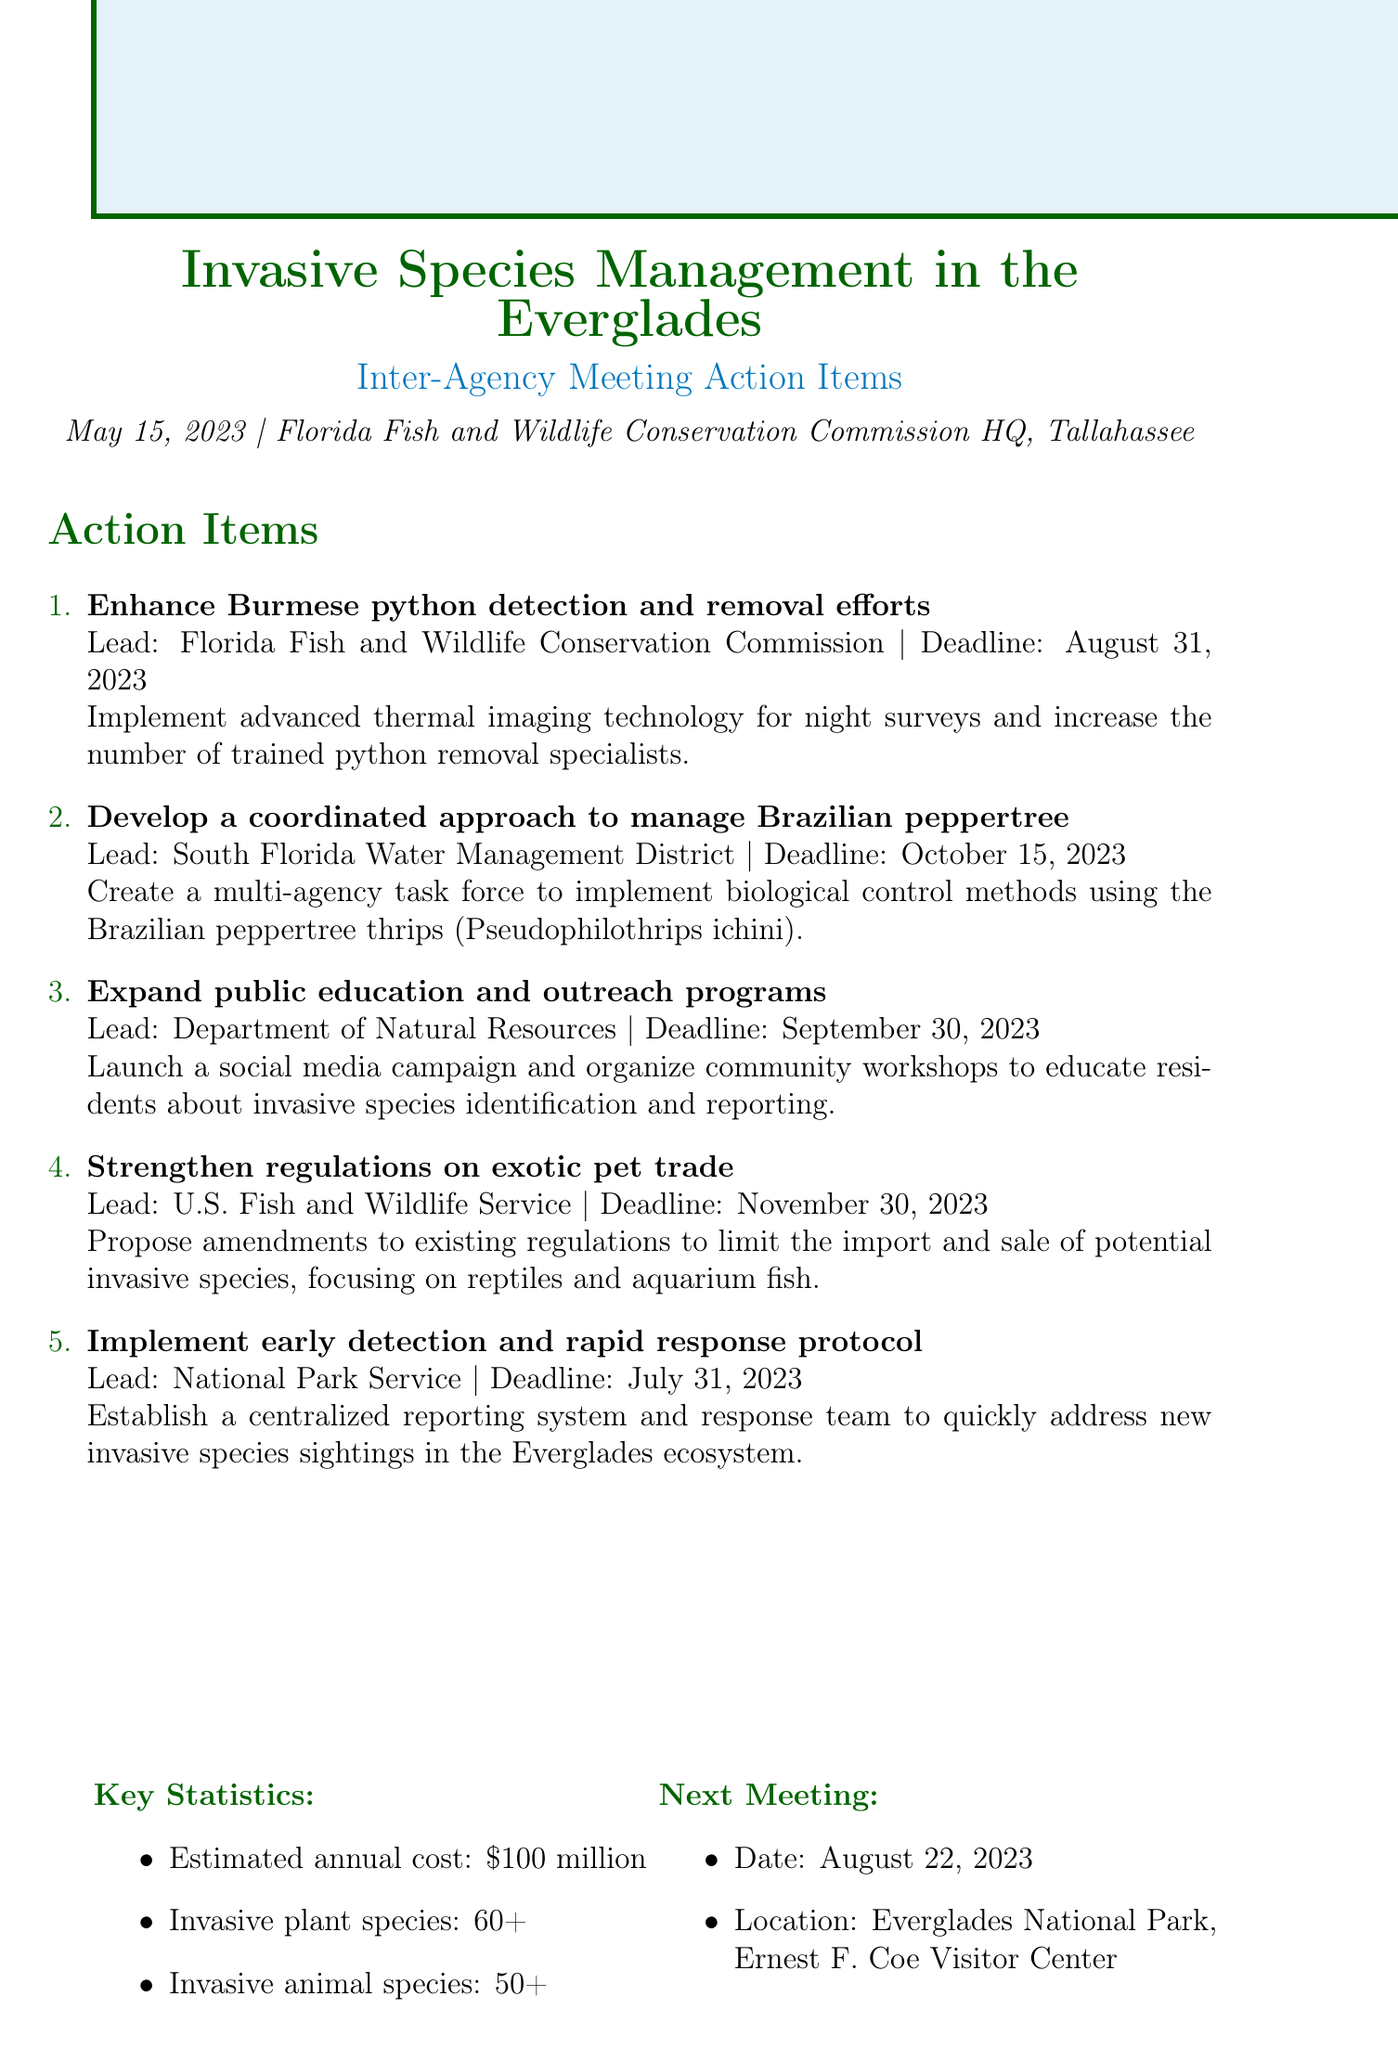What is the date of the meeting? The document states that the meeting was held on May 15, 2023.
Answer: May 15, 2023 Which agency is responsible for enhancing Burmese python removal efforts? The lead agency for this action item is mentioned in the document as the Florida Fish and Wildlife Conservation Commission.
Answer: Florida Fish and Wildlife Conservation Commission What is the deadline for the public education and outreach program? According to the action items, the deadline for this program is provided as September 30, 2023.
Answer: September 30, 2023 How many invasive plant species are estimated to be in the Everglades? The document specifies that there are 60+ invasive plant species.
Answer: 60+ What will be discussed in the next meeting? The next meeting location and date are noted, indicating that it will take place in Everglades National Park on August 22, 2023.
Answer: August 22, 2023 Who is tasked with developing a coordinated approach to manage Brazilian peppertree? The document lists the South Florida Water Management District as the lead agency for this action item.
Answer: South Florida Water Management District What technology is to be implemented for python detection efforts? The document highlights that advanced thermal imaging technology will be used for night surveys.
Answer: thermal imaging technology When is the proposed deadline for strengthening regulations on exotic pet trade? The document provides the deadline for this action item as November 30, 2023.
Answer: November 30, 2023 What is the estimated annual cost for managing invasive species? The document states that the estimated annual cost is $100 million.
Answer: $100 million 